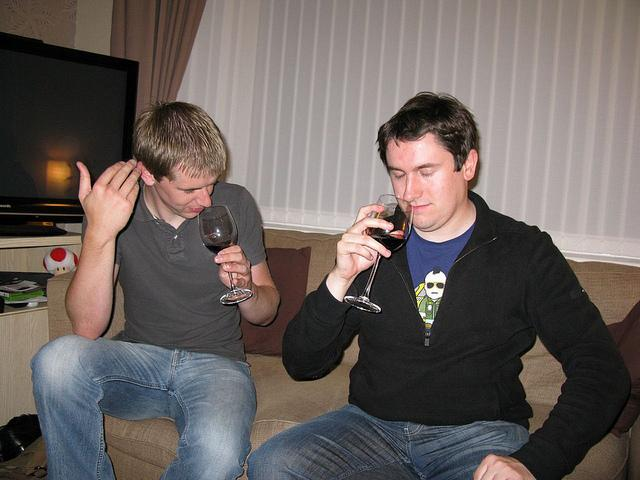Who manufactures the game that the stuffed animal is inspired by? nintendo 